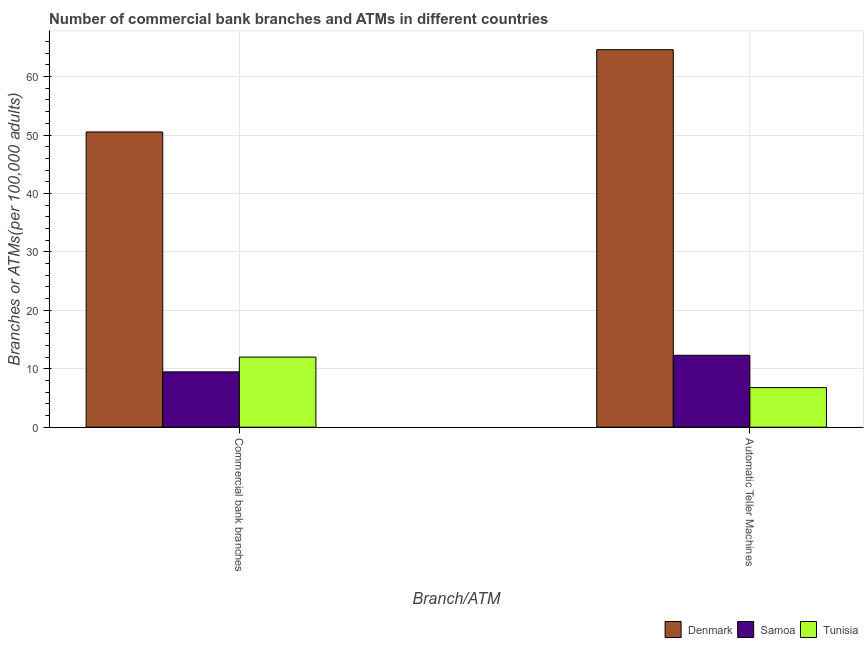How many different coloured bars are there?
Offer a very short reply. 3. How many groups of bars are there?
Your response must be concise. 2. How many bars are there on the 1st tick from the right?
Your answer should be compact. 3. What is the label of the 2nd group of bars from the left?
Ensure brevity in your answer.  Automatic Teller Machines. What is the number of commercal bank branches in Tunisia?
Offer a terse response. 12. Across all countries, what is the maximum number of atms?
Make the answer very short. 64.61. Across all countries, what is the minimum number of commercal bank branches?
Ensure brevity in your answer.  9.47. In which country was the number of atms minimum?
Offer a terse response. Tunisia. What is the total number of atms in the graph?
Keep it short and to the point. 83.69. What is the difference between the number of atms in Tunisia and that in Samoa?
Offer a terse response. -5.54. What is the difference between the number of atms in Denmark and the number of commercal bank branches in Tunisia?
Your answer should be compact. 52.61. What is the average number of atms per country?
Provide a succinct answer. 27.9. What is the difference between the number of atms and number of commercal bank branches in Tunisia?
Provide a short and direct response. -5.22. What is the ratio of the number of commercal bank branches in Samoa to that in Tunisia?
Make the answer very short. 0.79. Is the number of atms in Denmark less than that in Samoa?
Give a very brief answer. No. In how many countries, is the number of commercal bank branches greater than the average number of commercal bank branches taken over all countries?
Ensure brevity in your answer.  1. What does the 3rd bar from the left in Commercial bank branches represents?
Give a very brief answer. Tunisia. What does the 1st bar from the right in Commercial bank branches represents?
Your response must be concise. Tunisia. How many bars are there?
Ensure brevity in your answer.  6. How many countries are there in the graph?
Keep it short and to the point. 3. Does the graph contain any zero values?
Your answer should be very brief. No. How many legend labels are there?
Provide a short and direct response. 3. How are the legend labels stacked?
Make the answer very short. Horizontal. What is the title of the graph?
Offer a terse response. Number of commercial bank branches and ATMs in different countries. What is the label or title of the X-axis?
Your answer should be very brief. Branch/ATM. What is the label or title of the Y-axis?
Ensure brevity in your answer.  Branches or ATMs(per 100,0 adults). What is the Branches or ATMs(per 100,000 adults) of Denmark in Commercial bank branches?
Provide a short and direct response. 50.53. What is the Branches or ATMs(per 100,000 adults) of Samoa in Commercial bank branches?
Offer a terse response. 9.47. What is the Branches or ATMs(per 100,000 adults) in Tunisia in Commercial bank branches?
Make the answer very short. 12. What is the Branches or ATMs(per 100,000 adults) in Denmark in Automatic Teller Machines?
Your answer should be very brief. 64.61. What is the Branches or ATMs(per 100,000 adults) of Samoa in Automatic Teller Machines?
Make the answer very short. 12.31. What is the Branches or ATMs(per 100,000 adults) in Tunisia in Automatic Teller Machines?
Provide a succinct answer. 6.78. Across all Branch/ATM, what is the maximum Branches or ATMs(per 100,000 adults) of Denmark?
Keep it short and to the point. 64.61. Across all Branch/ATM, what is the maximum Branches or ATMs(per 100,000 adults) in Samoa?
Provide a short and direct response. 12.31. Across all Branch/ATM, what is the maximum Branches or ATMs(per 100,000 adults) in Tunisia?
Provide a short and direct response. 12. Across all Branch/ATM, what is the minimum Branches or ATMs(per 100,000 adults) in Denmark?
Provide a succinct answer. 50.53. Across all Branch/ATM, what is the minimum Branches or ATMs(per 100,000 adults) in Samoa?
Your answer should be very brief. 9.47. Across all Branch/ATM, what is the minimum Branches or ATMs(per 100,000 adults) of Tunisia?
Give a very brief answer. 6.78. What is the total Branches or ATMs(per 100,000 adults) of Denmark in the graph?
Your answer should be very brief. 115.13. What is the total Branches or ATMs(per 100,000 adults) of Samoa in the graph?
Make the answer very short. 21.79. What is the total Branches or ATMs(per 100,000 adults) in Tunisia in the graph?
Keep it short and to the point. 18.78. What is the difference between the Branches or ATMs(per 100,000 adults) of Denmark in Commercial bank branches and that in Automatic Teller Machines?
Make the answer very short. -14.08. What is the difference between the Branches or ATMs(per 100,000 adults) of Samoa in Commercial bank branches and that in Automatic Teller Machines?
Provide a short and direct response. -2.84. What is the difference between the Branches or ATMs(per 100,000 adults) of Tunisia in Commercial bank branches and that in Automatic Teller Machines?
Your answer should be compact. 5.22. What is the difference between the Branches or ATMs(per 100,000 adults) of Denmark in Commercial bank branches and the Branches or ATMs(per 100,000 adults) of Samoa in Automatic Teller Machines?
Provide a short and direct response. 38.21. What is the difference between the Branches or ATMs(per 100,000 adults) in Denmark in Commercial bank branches and the Branches or ATMs(per 100,000 adults) in Tunisia in Automatic Teller Machines?
Ensure brevity in your answer.  43.75. What is the difference between the Branches or ATMs(per 100,000 adults) of Samoa in Commercial bank branches and the Branches or ATMs(per 100,000 adults) of Tunisia in Automatic Teller Machines?
Provide a short and direct response. 2.7. What is the average Branches or ATMs(per 100,000 adults) of Denmark per Branch/ATM?
Give a very brief answer. 57.57. What is the average Branches or ATMs(per 100,000 adults) of Samoa per Branch/ATM?
Make the answer very short. 10.89. What is the average Branches or ATMs(per 100,000 adults) in Tunisia per Branch/ATM?
Make the answer very short. 9.39. What is the difference between the Branches or ATMs(per 100,000 adults) in Denmark and Branches or ATMs(per 100,000 adults) in Samoa in Commercial bank branches?
Provide a short and direct response. 41.05. What is the difference between the Branches or ATMs(per 100,000 adults) in Denmark and Branches or ATMs(per 100,000 adults) in Tunisia in Commercial bank branches?
Keep it short and to the point. 38.53. What is the difference between the Branches or ATMs(per 100,000 adults) of Samoa and Branches or ATMs(per 100,000 adults) of Tunisia in Commercial bank branches?
Offer a very short reply. -2.53. What is the difference between the Branches or ATMs(per 100,000 adults) in Denmark and Branches or ATMs(per 100,000 adults) in Samoa in Automatic Teller Machines?
Offer a terse response. 52.29. What is the difference between the Branches or ATMs(per 100,000 adults) in Denmark and Branches or ATMs(per 100,000 adults) in Tunisia in Automatic Teller Machines?
Your response must be concise. 57.83. What is the difference between the Branches or ATMs(per 100,000 adults) in Samoa and Branches or ATMs(per 100,000 adults) in Tunisia in Automatic Teller Machines?
Keep it short and to the point. 5.54. What is the ratio of the Branches or ATMs(per 100,000 adults) in Denmark in Commercial bank branches to that in Automatic Teller Machines?
Your response must be concise. 0.78. What is the ratio of the Branches or ATMs(per 100,000 adults) in Samoa in Commercial bank branches to that in Automatic Teller Machines?
Ensure brevity in your answer.  0.77. What is the ratio of the Branches or ATMs(per 100,000 adults) of Tunisia in Commercial bank branches to that in Automatic Teller Machines?
Make the answer very short. 1.77. What is the difference between the highest and the second highest Branches or ATMs(per 100,000 adults) in Denmark?
Ensure brevity in your answer.  14.08. What is the difference between the highest and the second highest Branches or ATMs(per 100,000 adults) in Samoa?
Your response must be concise. 2.84. What is the difference between the highest and the second highest Branches or ATMs(per 100,000 adults) of Tunisia?
Your answer should be compact. 5.22. What is the difference between the highest and the lowest Branches or ATMs(per 100,000 adults) of Denmark?
Keep it short and to the point. 14.08. What is the difference between the highest and the lowest Branches or ATMs(per 100,000 adults) in Samoa?
Provide a short and direct response. 2.84. What is the difference between the highest and the lowest Branches or ATMs(per 100,000 adults) in Tunisia?
Provide a succinct answer. 5.22. 